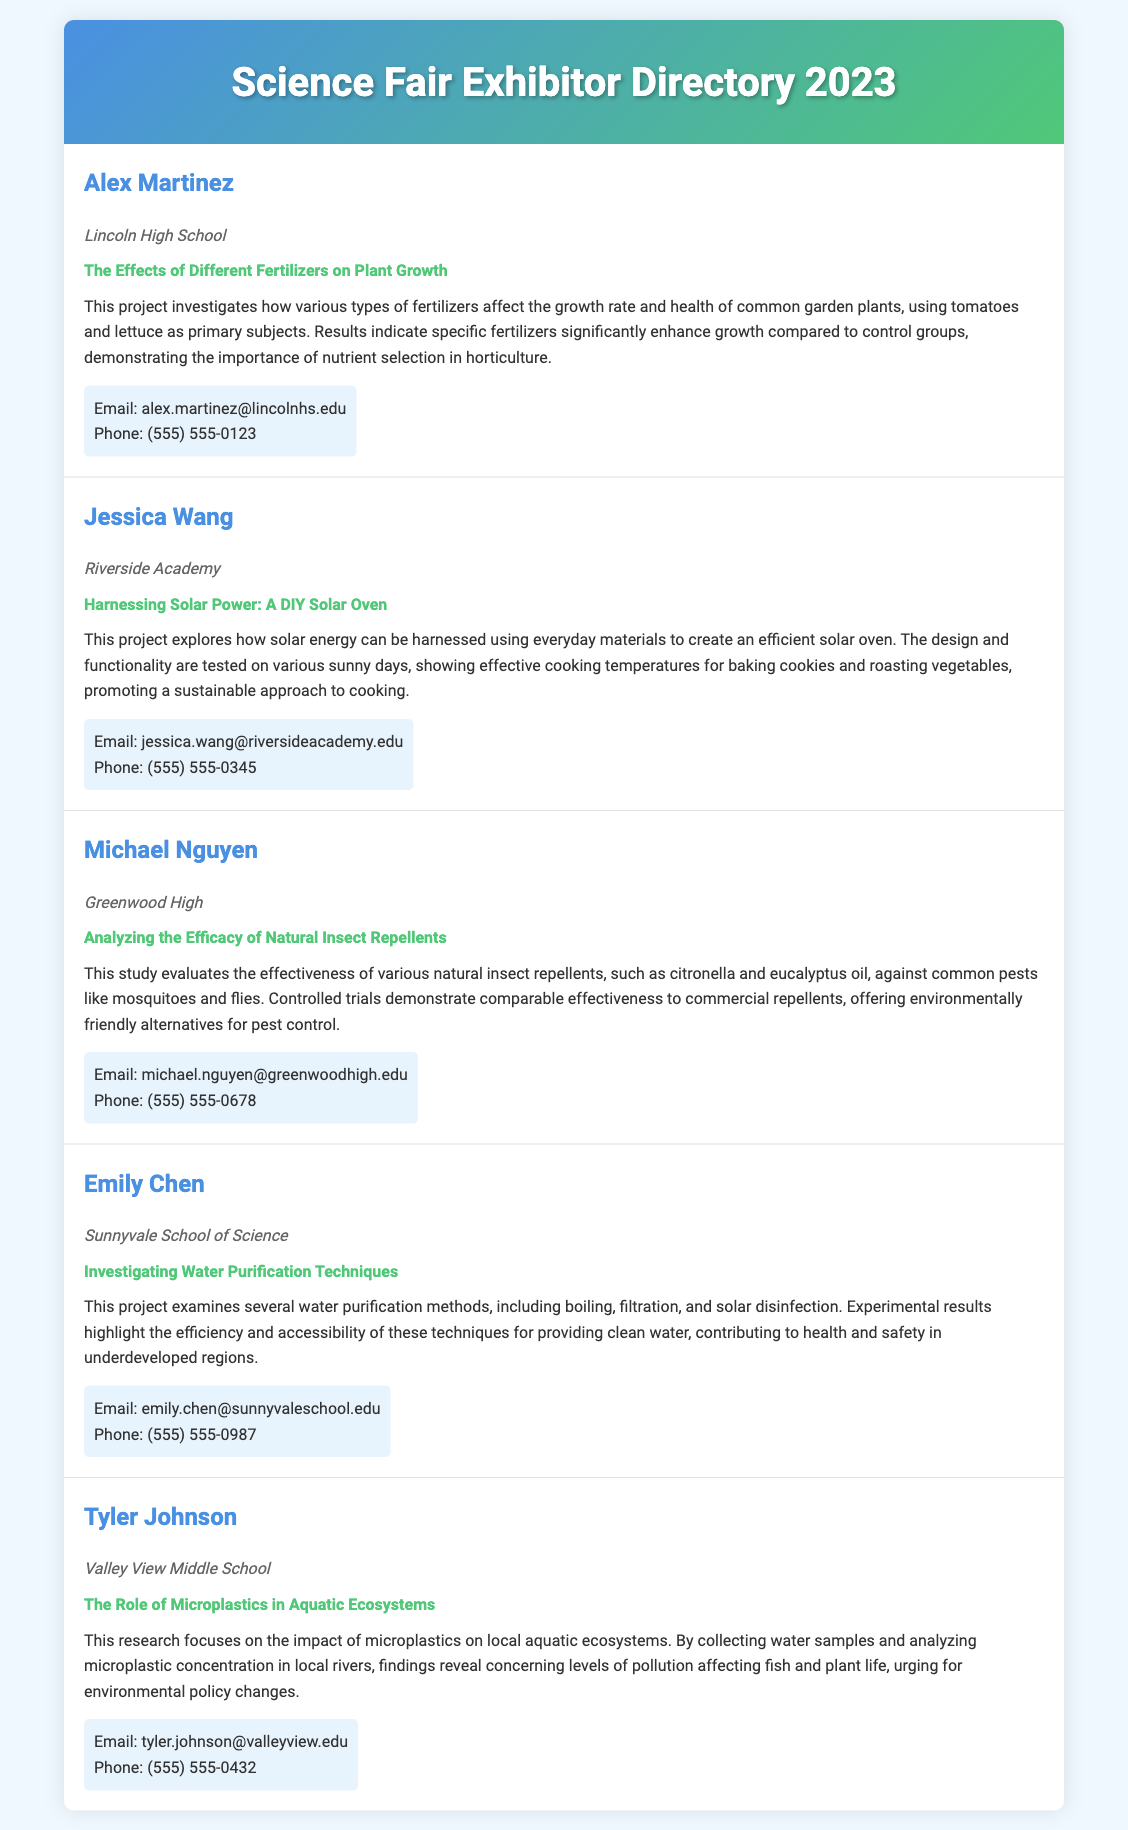What is Alex Martinez's project title? The project title can be retrieved from the section regarding Alex Martinez, which states "The Effects of Different Fertilizers on Plant Growth."
Answer: The Effects of Different Fertilizers on Plant Growth Which school does Jessica Wang attend? The school name is provided in Jessica Wang's profile, listed as "Riverside Academy."
Answer: Riverside Academy What is the main focus of Tyler Johnson's research? Tyler Johnson's research focuses on "the impact of microplastics on local aquatic ecosystems."
Answer: The impact of microplastics on local aquatic ecosystems How many participants are listed in the directory? The directory lists a total of five participants.
Answer: Five Which method of water purification does Emily Chen examine? Emily Chen examines "boiling, filtration, and solar disinfection" as water purification methods.
Answer: Boiling, filtration, and solar disinfection What is the email address provided for Michael Nguyen? The email address is stated in Michael Nguyen's section as "michael.nguyen@greenwoodhigh.edu."
Answer: michael.nguyen@greenwoodhigh.edu Which project emphasizes sustainability? Jessica Wang's project on "Harnessing Solar Power: A DIY Solar Oven" emphasizes sustainability.
Answer: Harnessing Solar Power: A DIY Solar Oven How does Alex Martinez's project contribute to horticulture? It indicates that "specific fertilizers significantly enhance growth" compared to control groups, showing horticultural importance.
Answer: Specific fertilizers significantly enhance growth What color theme is used in the document header? The color theme in the document header is a gradient from blue to green.
Answer: A gradient from blue to green 